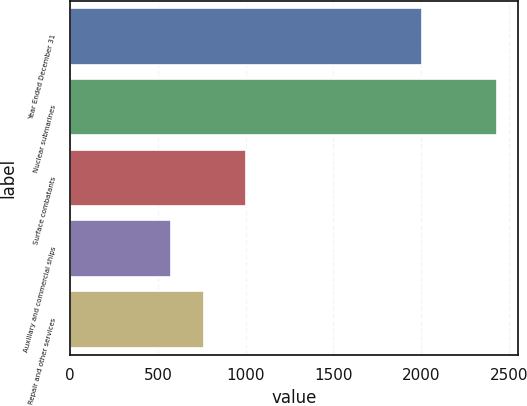<chart> <loc_0><loc_0><loc_500><loc_500><bar_chart><fcel>Year Ended December 31<fcel>Nuclear submarines<fcel>Surface combatants<fcel>Auxiliary and commercial ships<fcel>Repair and other services<nl><fcel>2004<fcel>2432<fcel>1002<fcel>576<fcel>761.6<nl></chart> 